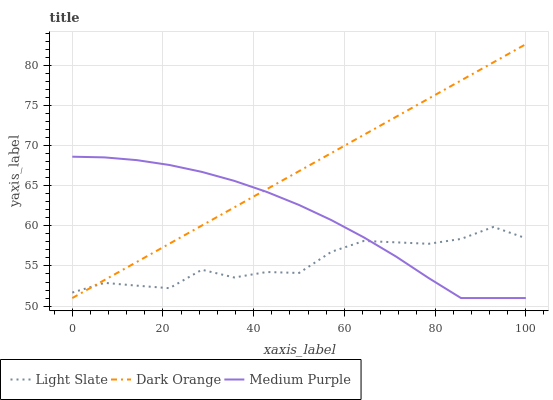Does Medium Purple have the minimum area under the curve?
Answer yes or no. No. Does Medium Purple have the maximum area under the curve?
Answer yes or no. No. Is Medium Purple the smoothest?
Answer yes or no. No. Is Medium Purple the roughest?
Answer yes or no. No. Does Medium Purple have the highest value?
Answer yes or no. No. 